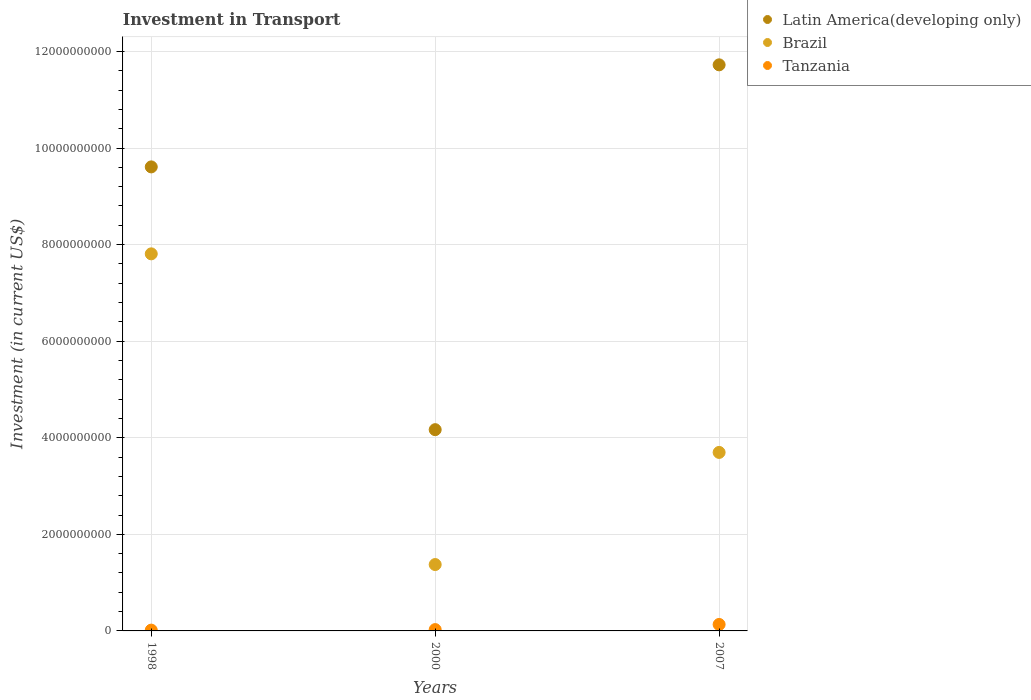How many different coloured dotlines are there?
Your response must be concise. 3. Is the number of dotlines equal to the number of legend labels?
Offer a terse response. Yes. What is the amount invested in transport in Brazil in 1998?
Keep it short and to the point. 7.81e+09. Across all years, what is the maximum amount invested in transport in Tanzania?
Your answer should be very brief. 1.34e+08. Across all years, what is the minimum amount invested in transport in Latin America(developing only)?
Keep it short and to the point. 4.17e+09. In which year was the amount invested in transport in Brazil maximum?
Offer a very short reply. 1998. What is the total amount invested in transport in Tanzania in the graph?
Your response must be concise. 1.78e+08. What is the difference between the amount invested in transport in Brazil in 1998 and that in 2000?
Provide a short and direct response. 6.43e+09. What is the difference between the amount invested in transport in Latin America(developing only) in 2000 and the amount invested in transport in Tanzania in 2007?
Your response must be concise. 4.03e+09. What is the average amount invested in transport in Latin America(developing only) per year?
Offer a very short reply. 8.50e+09. In the year 2007, what is the difference between the amount invested in transport in Latin America(developing only) and amount invested in transport in Brazil?
Keep it short and to the point. 8.03e+09. In how many years, is the amount invested in transport in Brazil greater than 7200000000 US$?
Your response must be concise. 1. What is the ratio of the amount invested in transport in Tanzania in 1998 to that in 2000?
Ensure brevity in your answer.  0.6. Is the difference between the amount invested in transport in Latin America(developing only) in 1998 and 2007 greater than the difference between the amount invested in transport in Brazil in 1998 and 2007?
Provide a short and direct response. No. What is the difference between the highest and the second highest amount invested in transport in Brazil?
Your answer should be very brief. 4.11e+09. What is the difference between the highest and the lowest amount invested in transport in Tanzania?
Keep it short and to the point. 1.18e+08. Is it the case that in every year, the sum of the amount invested in transport in Latin America(developing only) and amount invested in transport in Brazil  is greater than the amount invested in transport in Tanzania?
Your response must be concise. Yes. Is the amount invested in transport in Tanzania strictly greater than the amount invested in transport in Latin America(developing only) over the years?
Provide a short and direct response. No. Is the amount invested in transport in Brazil strictly less than the amount invested in transport in Latin America(developing only) over the years?
Provide a succinct answer. Yes. How many dotlines are there?
Your answer should be compact. 3. How many years are there in the graph?
Provide a short and direct response. 3. What is the difference between two consecutive major ticks on the Y-axis?
Your answer should be compact. 2.00e+09. Where does the legend appear in the graph?
Make the answer very short. Top right. How are the legend labels stacked?
Ensure brevity in your answer.  Vertical. What is the title of the graph?
Provide a succinct answer. Investment in Transport. Does "Djibouti" appear as one of the legend labels in the graph?
Offer a very short reply. No. What is the label or title of the Y-axis?
Offer a terse response. Investment (in current US$). What is the Investment (in current US$) in Latin America(developing only) in 1998?
Make the answer very short. 9.61e+09. What is the Investment (in current US$) of Brazil in 1998?
Your answer should be compact. 7.81e+09. What is the Investment (in current US$) of Tanzania in 1998?
Your answer should be compact. 1.65e+07. What is the Investment (in current US$) in Latin America(developing only) in 2000?
Keep it short and to the point. 4.17e+09. What is the Investment (in current US$) in Brazil in 2000?
Keep it short and to the point. 1.37e+09. What is the Investment (in current US$) of Tanzania in 2000?
Make the answer very short. 2.77e+07. What is the Investment (in current US$) in Latin America(developing only) in 2007?
Your response must be concise. 1.17e+1. What is the Investment (in current US$) of Brazil in 2007?
Offer a very short reply. 3.70e+09. What is the Investment (in current US$) in Tanzania in 2007?
Make the answer very short. 1.34e+08. Across all years, what is the maximum Investment (in current US$) of Latin America(developing only)?
Give a very brief answer. 1.17e+1. Across all years, what is the maximum Investment (in current US$) in Brazil?
Offer a very short reply. 7.81e+09. Across all years, what is the maximum Investment (in current US$) of Tanzania?
Your answer should be very brief. 1.34e+08. Across all years, what is the minimum Investment (in current US$) in Latin America(developing only)?
Make the answer very short. 4.17e+09. Across all years, what is the minimum Investment (in current US$) of Brazil?
Your answer should be very brief. 1.37e+09. Across all years, what is the minimum Investment (in current US$) of Tanzania?
Provide a short and direct response. 1.65e+07. What is the total Investment (in current US$) of Latin America(developing only) in the graph?
Your answer should be compact. 2.55e+1. What is the total Investment (in current US$) of Brazil in the graph?
Provide a succinct answer. 1.29e+1. What is the total Investment (in current US$) in Tanzania in the graph?
Your answer should be very brief. 1.78e+08. What is the difference between the Investment (in current US$) of Latin America(developing only) in 1998 and that in 2000?
Your answer should be compact. 5.44e+09. What is the difference between the Investment (in current US$) in Brazil in 1998 and that in 2000?
Make the answer very short. 6.43e+09. What is the difference between the Investment (in current US$) in Tanzania in 1998 and that in 2000?
Your answer should be compact. -1.12e+07. What is the difference between the Investment (in current US$) in Latin America(developing only) in 1998 and that in 2007?
Make the answer very short. -2.11e+09. What is the difference between the Investment (in current US$) of Brazil in 1998 and that in 2007?
Offer a very short reply. 4.11e+09. What is the difference between the Investment (in current US$) in Tanzania in 1998 and that in 2007?
Ensure brevity in your answer.  -1.18e+08. What is the difference between the Investment (in current US$) in Latin America(developing only) in 2000 and that in 2007?
Make the answer very short. -7.56e+09. What is the difference between the Investment (in current US$) in Brazil in 2000 and that in 2007?
Make the answer very short. -2.32e+09. What is the difference between the Investment (in current US$) of Tanzania in 2000 and that in 2007?
Offer a very short reply. -1.06e+08. What is the difference between the Investment (in current US$) in Latin America(developing only) in 1998 and the Investment (in current US$) in Brazil in 2000?
Your response must be concise. 8.23e+09. What is the difference between the Investment (in current US$) of Latin America(developing only) in 1998 and the Investment (in current US$) of Tanzania in 2000?
Your answer should be very brief. 9.58e+09. What is the difference between the Investment (in current US$) in Brazil in 1998 and the Investment (in current US$) in Tanzania in 2000?
Your answer should be compact. 7.78e+09. What is the difference between the Investment (in current US$) of Latin America(developing only) in 1998 and the Investment (in current US$) of Brazil in 2007?
Give a very brief answer. 5.91e+09. What is the difference between the Investment (in current US$) in Latin America(developing only) in 1998 and the Investment (in current US$) in Tanzania in 2007?
Your response must be concise. 9.48e+09. What is the difference between the Investment (in current US$) of Brazil in 1998 and the Investment (in current US$) of Tanzania in 2007?
Offer a very short reply. 7.67e+09. What is the difference between the Investment (in current US$) in Latin America(developing only) in 2000 and the Investment (in current US$) in Brazil in 2007?
Your answer should be very brief. 4.71e+08. What is the difference between the Investment (in current US$) of Latin America(developing only) in 2000 and the Investment (in current US$) of Tanzania in 2007?
Provide a succinct answer. 4.03e+09. What is the difference between the Investment (in current US$) of Brazil in 2000 and the Investment (in current US$) of Tanzania in 2007?
Provide a succinct answer. 1.24e+09. What is the average Investment (in current US$) of Latin America(developing only) per year?
Provide a succinct answer. 8.50e+09. What is the average Investment (in current US$) of Brazil per year?
Offer a terse response. 4.29e+09. What is the average Investment (in current US$) of Tanzania per year?
Make the answer very short. 5.94e+07. In the year 1998, what is the difference between the Investment (in current US$) in Latin America(developing only) and Investment (in current US$) in Brazil?
Keep it short and to the point. 1.80e+09. In the year 1998, what is the difference between the Investment (in current US$) of Latin America(developing only) and Investment (in current US$) of Tanzania?
Your response must be concise. 9.59e+09. In the year 1998, what is the difference between the Investment (in current US$) in Brazil and Investment (in current US$) in Tanzania?
Offer a very short reply. 7.79e+09. In the year 2000, what is the difference between the Investment (in current US$) in Latin America(developing only) and Investment (in current US$) in Brazil?
Ensure brevity in your answer.  2.79e+09. In the year 2000, what is the difference between the Investment (in current US$) of Latin America(developing only) and Investment (in current US$) of Tanzania?
Your response must be concise. 4.14e+09. In the year 2000, what is the difference between the Investment (in current US$) in Brazil and Investment (in current US$) in Tanzania?
Offer a terse response. 1.35e+09. In the year 2007, what is the difference between the Investment (in current US$) of Latin America(developing only) and Investment (in current US$) of Brazil?
Offer a very short reply. 8.03e+09. In the year 2007, what is the difference between the Investment (in current US$) of Latin America(developing only) and Investment (in current US$) of Tanzania?
Ensure brevity in your answer.  1.16e+1. In the year 2007, what is the difference between the Investment (in current US$) of Brazil and Investment (in current US$) of Tanzania?
Offer a terse response. 3.56e+09. What is the ratio of the Investment (in current US$) in Latin America(developing only) in 1998 to that in 2000?
Keep it short and to the point. 2.31. What is the ratio of the Investment (in current US$) of Brazil in 1998 to that in 2000?
Give a very brief answer. 5.68. What is the ratio of the Investment (in current US$) of Tanzania in 1998 to that in 2000?
Your answer should be very brief. 0.6. What is the ratio of the Investment (in current US$) in Latin America(developing only) in 1998 to that in 2007?
Your response must be concise. 0.82. What is the ratio of the Investment (in current US$) in Brazil in 1998 to that in 2007?
Ensure brevity in your answer.  2.11. What is the ratio of the Investment (in current US$) of Tanzania in 1998 to that in 2007?
Your answer should be very brief. 0.12. What is the ratio of the Investment (in current US$) of Latin America(developing only) in 2000 to that in 2007?
Keep it short and to the point. 0.36. What is the ratio of the Investment (in current US$) in Brazil in 2000 to that in 2007?
Provide a short and direct response. 0.37. What is the ratio of the Investment (in current US$) of Tanzania in 2000 to that in 2007?
Offer a very short reply. 0.21. What is the difference between the highest and the second highest Investment (in current US$) in Latin America(developing only)?
Offer a terse response. 2.11e+09. What is the difference between the highest and the second highest Investment (in current US$) of Brazil?
Make the answer very short. 4.11e+09. What is the difference between the highest and the second highest Investment (in current US$) of Tanzania?
Offer a very short reply. 1.06e+08. What is the difference between the highest and the lowest Investment (in current US$) of Latin America(developing only)?
Your answer should be very brief. 7.56e+09. What is the difference between the highest and the lowest Investment (in current US$) of Brazil?
Offer a terse response. 6.43e+09. What is the difference between the highest and the lowest Investment (in current US$) in Tanzania?
Your response must be concise. 1.18e+08. 